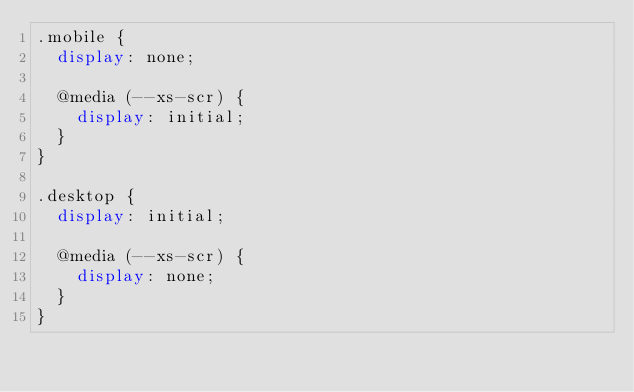Convert code to text. <code><loc_0><loc_0><loc_500><loc_500><_CSS_>.mobile {
  display: none;

  @media (--xs-scr) {
    display: initial;
  }
}

.desktop {
  display: initial;

  @media (--xs-scr) {
    display: none;
  }
}
</code> 